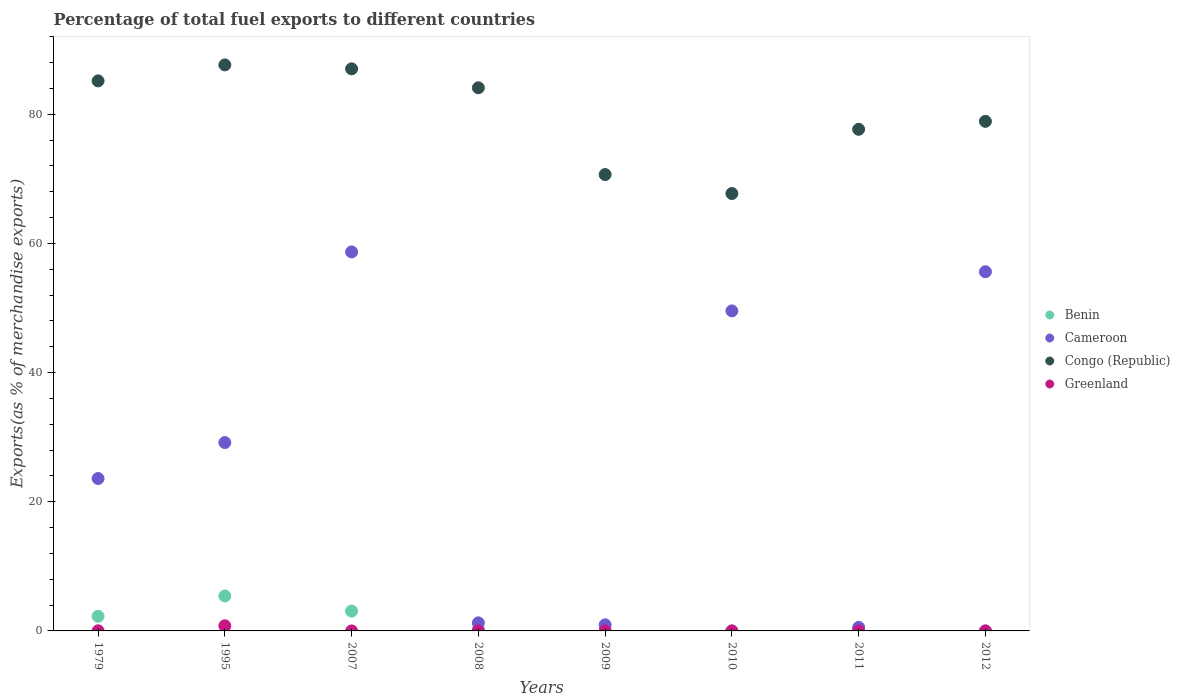How many different coloured dotlines are there?
Provide a succinct answer. 4. Is the number of dotlines equal to the number of legend labels?
Your response must be concise. Yes. What is the percentage of exports to different countries in Greenland in 1979?
Your answer should be very brief. 0.02. Across all years, what is the maximum percentage of exports to different countries in Benin?
Provide a succinct answer. 5.42. Across all years, what is the minimum percentage of exports to different countries in Benin?
Offer a terse response. 0.01. In which year was the percentage of exports to different countries in Congo (Republic) maximum?
Keep it short and to the point. 1995. What is the total percentage of exports to different countries in Greenland in the graph?
Provide a short and direct response. 0.81. What is the difference between the percentage of exports to different countries in Benin in 2010 and that in 2012?
Provide a succinct answer. 0.01. What is the difference between the percentage of exports to different countries in Congo (Republic) in 1979 and the percentage of exports to different countries in Benin in 2011?
Ensure brevity in your answer.  85.06. What is the average percentage of exports to different countries in Greenland per year?
Offer a very short reply. 0.1. In the year 2008, what is the difference between the percentage of exports to different countries in Cameroon and percentage of exports to different countries in Benin?
Provide a succinct answer. 0.98. What is the ratio of the percentage of exports to different countries in Congo (Republic) in 2007 to that in 2012?
Keep it short and to the point. 1.1. Is the difference between the percentage of exports to different countries in Cameroon in 2007 and 2012 greater than the difference between the percentage of exports to different countries in Benin in 2007 and 2012?
Your answer should be compact. Yes. What is the difference between the highest and the second highest percentage of exports to different countries in Benin?
Your answer should be compact. 2.35. What is the difference between the highest and the lowest percentage of exports to different countries in Greenland?
Ensure brevity in your answer.  0.79. Is the percentage of exports to different countries in Greenland strictly greater than the percentage of exports to different countries in Cameroon over the years?
Keep it short and to the point. No. Is the percentage of exports to different countries in Cameroon strictly less than the percentage of exports to different countries in Greenland over the years?
Offer a very short reply. No. How many dotlines are there?
Offer a very short reply. 4. What is the difference between two consecutive major ticks on the Y-axis?
Ensure brevity in your answer.  20. Does the graph contain any zero values?
Ensure brevity in your answer.  No. Where does the legend appear in the graph?
Provide a succinct answer. Center right. What is the title of the graph?
Offer a very short reply. Percentage of total fuel exports to different countries. What is the label or title of the X-axis?
Your answer should be compact. Years. What is the label or title of the Y-axis?
Give a very brief answer. Exports(as % of merchandise exports). What is the Exports(as % of merchandise exports) in Benin in 1979?
Your answer should be very brief. 2.27. What is the Exports(as % of merchandise exports) of Cameroon in 1979?
Provide a succinct answer. 23.6. What is the Exports(as % of merchandise exports) in Congo (Republic) in 1979?
Keep it short and to the point. 85.16. What is the Exports(as % of merchandise exports) in Greenland in 1979?
Provide a short and direct response. 0.02. What is the Exports(as % of merchandise exports) of Benin in 1995?
Give a very brief answer. 5.42. What is the Exports(as % of merchandise exports) of Cameroon in 1995?
Offer a very short reply. 29.16. What is the Exports(as % of merchandise exports) in Congo (Republic) in 1995?
Make the answer very short. 87.64. What is the Exports(as % of merchandise exports) in Greenland in 1995?
Make the answer very short. 0.79. What is the Exports(as % of merchandise exports) of Benin in 2007?
Offer a terse response. 3.07. What is the Exports(as % of merchandise exports) in Cameroon in 2007?
Give a very brief answer. 58.68. What is the Exports(as % of merchandise exports) of Congo (Republic) in 2007?
Ensure brevity in your answer.  87.02. What is the Exports(as % of merchandise exports) of Greenland in 2007?
Offer a terse response. 1.67003405452262e-5. What is the Exports(as % of merchandise exports) of Benin in 2008?
Your answer should be very brief. 0.27. What is the Exports(as % of merchandise exports) in Cameroon in 2008?
Provide a succinct answer. 1.25. What is the Exports(as % of merchandise exports) of Congo (Republic) in 2008?
Your answer should be compact. 84.09. What is the Exports(as % of merchandise exports) of Greenland in 2008?
Your answer should be very brief. 0. What is the Exports(as % of merchandise exports) of Benin in 2009?
Give a very brief answer. 0.01. What is the Exports(as % of merchandise exports) of Cameroon in 2009?
Offer a terse response. 0.95. What is the Exports(as % of merchandise exports) in Congo (Republic) in 2009?
Offer a terse response. 70.66. What is the Exports(as % of merchandise exports) in Greenland in 2009?
Provide a short and direct response. 6.028633814473571e-5. What is the Exports(as % of merchandise exports) of Benin in 2010?
Provide a short and direct response. 0.01. What is the Exports(as % of merchandise exports) in Cameroon in 2010?
Keep it short and to the point. 49.55. What is the Exports(as % of merchandise exports) in Congo (Republic) in 2010?
Provide a short and direct response. 67.72. What is the Exports(as % of merchandise exports) of Greenland in 2010?
Ensure brevity in your answer.  0. What is the Exports(as % of merchandise exports) of Benin in 2011?
Provide a succinct answer. 0.11. What is the Exports(as % of merchandise exports) of Cameroon in 2011?
Your answer should be compact. 0.55. What is the Exports(as % of merchandise exports) of Congo (Republic) in 2011?
Your answer should be very brief. 77.67. What is the Exports(as % of merchandise exports) of Greenland in 2011?
Keep it short and to the point. 0. What is the Exports(as % of merchandise exports) in Benin in 2012?
Ensure brevity in your answer.  0.01. What is the Exports(as % of merchandise exports) in Cameroon in 2012?
Offer a terse response. 55.61. What is the Exports(as % of merchandise exports) of Congo (Republic) in 2012?
Give a very brief answer. 78.9. What is the Exports(as % of merchandise exports) in Greenland in 2012?
Make the answer very short. 0. Across all years, what is the maximum Exports(as % of merchandise exports) in Benin?
Offer a terse response. 5.42. Across all years, what is the maximum Exports(as % of merchandise exports) in Cameroon?
Provide a succinct answer. 58.68. Across all years, what is the maximum Exports(as % of merchandise exports) in Congo (Republic)?
Your answer should be compact. 87.64. Across all years, what is the maximum Exports(as % of merchandise exports) of Greenland?
Provide a short and direct response. 0.79. Across all years, what is the minimum Exports(as % of merchandise exports) in Benin?
Your answer should be compact. 0.01. Across all years, what is the minimum Exports(as % of merchandise exports) of Cameroon?
Your response must be concise. 0.55. Across all years, what is the minimum Exports(as % of merchandise exports) in Congo (Republic)?
Make the answer very short. 67.72. Across all years, what is the minimum Exports(as % of merchandise exports) in Greenland?
Provide a short and direct response. 1.67003405452262e-5. What is the total Exports(as % of merchandise exports) of Benin in the graph?
Give a very brief answer. 11.15. What is the total Exports(as % of merchandise exports) in Cameroon in the graph?
Give a very brief answer. 219.35. What is the total Exports(as % of merchandise exports) in Congo (Republic) in the graph?
Give a very brief answer. 638.87. What is the total Exports(as % of merchandise exports) in Greenland in the graph?
Make the answer very short. 0.81. What is the difference between the Exports(as % of merchandise exports) of Benin in 1979 and that in 1995?
Your answer should be very brief. -3.15. What is the difference between the Exports(as % of merchandise exports) of Cameroon in 1979 and that in 1995?
Offer a very short reply. -5.57. What is the difference between the Exports(as % of merchandise exports) of Congo (Republic) in 1979 and that in 1995?
Ensure brevity in your answer.  -2.48. What is the difference between the Exports(as % of merchandise exports) of Greenland in 1979 and that in 1995?
Give a very brief answer. -0.77. What is the difference between the Exports(as % of merchandise exports) in Benin in 1979 and that in 2007?
Your answer should be compact. -0.8. What is the difference between the Exports(as % of merchandise exports) of Cameroon in 1979 and that in 2007?
Your answer should be compact. -35.08. What is the difference between the Exports(as % of merchandise exports) in Congo (Republic) in 1979 and that in 2007?
Make the answer very short. -1.86. What is the difference between the Exports(as % of merchandise exports) of Greenland in 1979 and that in 2007?
Make the answer very short. 0.02. What is the difference between the Exports(as % of merchandise exports) of Benin in 1979 and that in 2008?
Ensure brevity in your answer.  2. What is the difference between the Exports(as % of merchandise exports) in Cameroon in 1979 and that in 2008?
Make the answer very short. 22.35. What is the difference between the Exports(as % of merchandise exports) in Congo (Republic) in 1979 and that in 2008?
Provide a succinct answer. 1.07. What is the difference between the Exports(as % of merchandise exports) in Greenland in 1979 and that in 2008?
Your response must be concise. 0.02. What is the difference between the Exports(as % of merchandise exports) in Benin in 1979 and that in 2009?
Offer a very short reply. 2.26. What is the difference between the Exports(as % of merchandise exports) of Cameroon in 1979 and that in 2009?
Your answer should be compact. 22.65. What is the difference between the Exports(as % of merchandise exports) in Congo (Republic) in 1979 and that in 2009?
Ensure brevity in your answer.  14.5. What is the difference between the Exports(as % of merchandise exports) in Greenland in 1979 and that in 2009?
Give a very brief answer. 0.02. What is the difference between the Exports(as % of merchandise exports) in Benin in 1979 and that in 2010?
Give a very brief answer. 2.26. What is the difference between the Exports(as % of merchandise exports) in Cameroon in 1979 and that in 2010?
Provide a succinct answer. -25.95. What is the difference between the Exports(as % of merchandise exports) in Congo (Republic) in 1979 and that in 2010?
Keep it short and to the point. 17.44. What is the difference between the Exports(as % of merchandise exports) in Greenland in 1979 and that in 2010?
Your answer should be compact. 0.02. What is the difference between the Exports(as % of merchandise exports) of Benin in 1979 and that in 2011?
Offer a terse response. 2.16. What is the difference between the Exports(as % of merchandise exports) in Cameroon in 1979 and that in 2011?
Provide a succinct answer. 23.05. What is the difference between the Exports(as % of merchandise exports) of Congo (Republic) in 1979 and that in 2011?
Your response must be concise. 7.5. What is the difference between the Exports(as % of merchandise exports) in Greenland in 1979 and that in 2011?
Provide a short and direct response. 0.02. What is the difference between the Exports(as % of merchandise exports) in Benin in 1979 and that in 2012?
Your response must be concise. 2.27. What is the difference between the Exports(as % of merchandise exports) of Cameroon in 1979 and that in 2012?
Ensure brevity in your answer.  -32.01. What is the difference between the Exports(as % of merchandise exports) of Congo (Republic) in 1979 and that in 2012?
Keep it short and to the point. 6.26. What is the difference between the Exports(as % of merchandise exports) in Greenland in 1979 and that in 2012?
Give a very brief answer. 0.02. What is the difference between the Exports(as % of merchandise exports) of Benin in 1995 and that in 2007?
Keep it short and to the point. 2.35. What is the difference between the Exports(as % of merchandise exports) in Cameroon in 1995 and that in 2007?
Make the answer very short. -29.52. What is the difference between the Exports(as % of merchandise exports) in Congo (Republic) in 1995 and that in 2007?
Your answer should be compact. 0.62. What is the difference between the Exports(as % of merchandise exports) in Greenland in 1995 and that in 2007?
Keep it short and to the point. 0.79. What is the difference between the Exports(as % of merchandise exports) in Benin in 1995 and that in 2008?
Offer a terse response. 5.15. What is the difference between the Exports(as % of merchandise exports) in Cameroon in 1995 and that in 2008?
Provide a succinct answer. 27.92. What is the difference between the Exports(as % of merchandise exports) of Congo (Republic) in 1995 and that in 2008?
Your response must be concise. 3.55. What is the difference between the Exports(as % of merchandise exports) in Greenland in 1995 and that in 2008?
Your response must be concise. 0.79. What is the difference between the Exports(as % of merchandise exports) of Benin in 1995 and that in 2009?
Offer a terse response. 5.41. What is the difference between the Exports(as % of merchandise exports) in Cameroon in 1995 and that in 2009?
Give a very brief answer. 28.22. What is the difference between the Exports(as % of merchandise exports) of Congo (Republic) in 1995 and that in 2009?
Make the answer very short. 16.98. What is the difference between the Exports(as % of merchandise exports) of Greenland in 1995 and that in 2009?
Your answer should be compact. 0.79. What is the difference between the Exports(as % of merchandise exports) in Benin in 1995 and that in 2010?
Provide a succinct answer. 5.4. What is the difference between the Exports(as % of merchandise exports) in Cameroon in 1995 and that in 2010?
Your answer should be very brief. -20.38. What is the difference between the Exports(as % of merchandise exports) of Congo (Republic) in 1995 and that in 2010?
Provide a succinct answer. 19.92. What is the difference between the Exports(as % of merchandise exports) of Greenland in 1995 and that in 2010?
Give a very brief answer. 0.79. What is the difference between the Exports(as % of merchandise exports) in Benin in 1995 and that in 2011?
Provide a short and direct response. 5.31. What is the difference between the Exports(as % of merchandise exports) of Cameroon in 1995 and that in 2011?
Offer a terse response. 28.61. What is the difference between the Exports(as % of merchandise exports) of Congo (Republic) in 1995 and that in 2011?
Offer a very short reply. 9.97. What is the difference between the Exports(as % of merchandise exports) of Greenland in 1995 and that in 2011?
Provide a succinct answer. 0.79. What is the difference between the Exports(as % of merchandise exports) in Benin in 1995 and that in 2012?
Keep it short and to the point. 5.41. What is the difference between the Exports(as % of merchandise exports) in Cameroon in 1995 and that in 2012?
Your response must be concise. -26.45. What is the difference between the Exports(as % of merchandise exports) of Congo (Republic) in 1995 and that in 2012?
Give a very brief answer. 8.74. What is the difference between the Exports(as % of merchandise exports) of Greenland in 1995 and that in 2012?
Your response must be concise. 0.79. What is the difference between the Exports(as % of merchandise exports) of Benin in 2007 and that in 2008?
Keep it short and to the point. 2.8. What is the difference between the Exports(as % of merchandise exports) in Cameroon in 2007 and that in 2008?
Give a very brief answer. 57.43. What is the difference between the Exports(as % of merchandise exports) in Congo (Republic) in 2007 and that in 2008?
Provide a succinct answer. 2.93. What is the difference between the Exports(as % of merchandise exports) of Greenland in 2007 and that in 2008?
Offer a terse response. -0. What is the difference between the Exports(as % of merchandise exports) in Benin in 2007 and that in 2009?
Make the answer very short. 3.06. What is the difference between the Exports(as % of merchandise exports) of Cameroon in 2007 and that in 2009?
Give a very brief answer. 57.73. What is the difference between the Exports(as % of merchandise exports) of Congo (Republic) in 2007 and that in 2009?
Your answer should be compact. 16.37. What is the difference between the Exports(as % of merchandise exports) in Benin in 2007 and that in 2010?
Your answer should be compact. 3.06. What is the difference between the Exports(as % of merchandise exports) of Cameroon in 2007 and that in 2010?
Your response must be concise. 9.13. What is the difference between the Exports(as % of merchandise exports) of Congo (Republic) in 2007 and that in 2010?
Your answer should be compact. 19.3. What is the difference between the Exports(as % of merchandise exports) of Greenland in 2007 and that in 2010?
Your answer should be compact. -0. What is the difference between the Exports(as % of merchandise exports) of Benin in 2007 and that in 2011?
Keep it short and to the point. 2.96. What is the difference between the Exports(as % of merchandise exports) of Cameroon in 2007 and that in 2011?
Your response must be concise. 58.13. What is the difference between the Exports(as % of merchandise exports) of Congo (Republic) in 2007 and that in 2011?
Provide a succinct answer. 9.36. What is the difference between the Exports(as % of merchandise exports) of Greenland in 2007 and that in 2011?
Make the answer very short. -0. What is the difference between the Exports(as % of merchandise exports) in Benin in 2007 and that in 2012?
Your response must be concise. 3.06. What is the difference between the Exports(as % of merchandise exports) in Cameroon in 2007 and that in 2012?
Provide a succinct answer. 3.07. What is the difference between the Exports(as % of merchandise exports) in Congo (Republic) in 2007 and that in 2012?
Ensure brevity in your answer.  8.13. What is the difference between the Exports(as % of merchandise exports) in Greenland in 2007 and that in 2012?
Provide a short and direct response. -0. What is the difference between the Exports(as % of merchandise exports) of Benin in 2008 and that in 2009?
Your answer should be compact. 0.26. What is the difference between the Exports(as % of merchandise exports) in Cameroon in 2008 and that in 2009?
Provide a succinct answer. 0.3. What is the difference between the Exports(as % of merchandise exports) of Congo (Republic) in 2008 and that in 2009?
Your response must be concise. 13.44. What is the difference between the Exports(as % of merchandise exports) in Benin in 2008 and that in 2010?
Make the answer very short. 0.26. What is the difference between the Exports(as % of merchandise exports) in Cameroon in 2008 and that in 2010?
Ensure brevity in your answer.  -48.3. What is the difference between the Exports(as % of merchandise exports) of Congo (Republic) in 2008 and that in 2010?
Keep it short and to the point. 16.37. What is the difference between the Exports(as % of merchandise exports) in Greenland in 2008 and that in 2010?
Provide a succinct answer. -0. What is the difference between the Exports(as % of merchandise exports) of Benin in 2008 and that in 2011?
Give a very brief answer. 0.16. What is the difference between the Exports(as % of merchandise exports) in Cameroon in 2008 and that in 2011?
Ensure brevity in your answer.  0.69. What is the difference between the Exports(as % of merchandise exports) in Congo (Republic) in 2008 and that in 2011?
Ensure brevity in your answer.  6.43. What is the difference between the Exports(as % of merchandise exports) of Greenland in 2008 and that in 2011?
Offer a very short reply. 0. What is the difference between the Exports(as % of merchandise exports) in Benin in 2008 and that in 2012?
Keep it short and to the point. 0.26. What is the difference between the Exports(as % of merchandise exports) of Cameroon in 2008 and that in 2012?
Offer a terse response. -54.36. What is the difference between the Exports(as % of merchandise exports) in Congo (Republic) in 2008 and that in 2012?
Make the answer very short. 5.2. What is the difference between the Exports(as % of merchandise exports) in Benin in 2009 and that in 2010?
Offer a very short reply. -0. What is the difference between the Exports(as % of merchandise exports) in Cameroon in 2009 and that in 2010?
Your response must be concise. -48.6. What is the difference between the Exports(as % of merchandise exports) in Congo (Republic) in 2009 and that in 2010?
Ensure brevity in your answer.  2.94. What is the difference between the Exports(as % of merchandise exports) of Greenland in 2009 and that in 2010?
Provide a succinct answer. -0. What is the difference between the Exports(as % of merchandise exports) of Benin in 2009 and that in 2011?
Give a very brief answer. -0.1. What is the difference between the Exports(as % of merchandise exports) of Cameroon in 2009 and that in 2011?
Your answer should be compact. 0.4. What is the difference between the Exports(as % of merchandise exports) of Congo (Republic) in 2009 and that in 2011?
Make the answer very short. -7.01. What is the difference between the Exports(as % of merchandise exports) of Greenland in 2009 and that in 2011?
Provide a succinct answer. -0. What is the difference between the Exports(as % of merchandise exports) of Benin in 2009 and that in 2012?
Provide a short and direct response. 0. What is the difference between the Exports(as % of merchandise exports) of Cameroon in 2009 and that in 2012?
Your answer should be very brief. -54.66. What is the difference between the Exports(as % of merchandise exports) in Congo (Republic) in 2009 and that in 2012?
Offer a terse response. -8.24. What is the difference between the Exports(as % of merchandise exports) of Greenland in 2009 and that in 2012?
Ensure brevity in your answer.  -0. What is the difference between the Exports(as % of merchandise exports) of Benin in 2010 and that in 2011?
Ensure brevity in your answer.  -0.09. What is the difference between the Exports(as % of merchandise exports) in Cameroon in 2010 and that in 2011?
Your response must be concise. 49. What is the difference between the Exports(as % of merchandise exports) of Congo (Republic) in 2010 and that in 2011?
Give a very brief answer. -9.95. What is the difference between the Exports(as % of merchandise exports) of Greenland in 2010 and that in 2011?
Make the answer very short. 0. What is the difference between the Exports(as % of merchandise exports) of Benin in 2010 and that in 2012?
Offer a very short reply. 0.01. What is the difference between the Exports(as % of merchandise exports) in Cameroon in 2010 and that in 2012?
Keep it short and to the point. -6.06. What is the difference between the Exports(as % of merchandise exports) of Congo (Republic) in 2010 and that in 2012?
Your answer should be very brief. -11.18. What is the difference between the Exports(as % of merchandise exports) in Greenland in 2010 and that in 2012?
Your answer should be compact. 0. What is the difference between the Exports(as % of merchandise exports) in Benin in 2011 and that in 2012?
Your answer should be very brief. 0.1. What is the difference between the Exports(as % of merchandise exports) in Cameroon in 2011 and that in 2012?
Offer a very short reply. -55.06. What is the difference between the Exports(as % of merchandise exports) in Congo (Republic) in 2011 and that in 2012?
Your response must be concise. -1.23. What is the difference between the Exports(as % of merchandise exports) of Greenland in 2011 and that in 2012?
Provide a succinct answer. 0. What is the difference between the Exports(as % of merchandise exports) of Benin in 1979 and the Exports(as % of merchandise exports) of Cameroon in 1995?
Your answer should be compact. -26.89. What is the difference between the Exports(as % of merchandise exports) of Benin in 1979 and the Exports(as % of merchandise exports) of Congo (Republic) in 1995?
Your answer should be very brief. -85.37. What is the difference between the Exports(as % of merchandise exports) of Benin in 1979 and the Exports(as % of merchandise exports) of Greenland in 1995?
Make the answer very short. 1.48. What is the difference between the Exports(as % of merchandise exports) of Cameroon in 1979 and the Exports(as % of merchandise exports) of Congo (Republic) in 1995?
Provide a succinct answer. -64.04. What is the difference between the Exports(as % of merchandise exports) of Cameroon in 1979 and the Exports(as % of merchandise exports) of Greenland in 1995?
Give a very brief answer. 22.8. What is the difference between the Exports(as % of merchandise exports) of Congo (Republic) in 1979 and the Exports(as % of merchandise exports) of Greenland in 1995?
Your answer should be compact. 84.37. What is the difference between the Exports(as % of merchandise exports) in Benin in 1979 and the Exports(as % of merchandise exports) in Cameroon in 2007?
Give a very brief answer. -56.41. What is the difference between the Exports(as % of merchandise exports) of Benin in 1979 and the Exports(as % of merchandise exports) of Congo (Republic) in 2007?
Keep it short and to the point. -84.75. What is the difference between the Exports(as % of merchandise exports) in Benin in 1979 and the Exports(as % of merchandise exports) in Greenland in 2007?
Your answer should be very brief. 2.27. What is the difference between the Exports(as % of merchandise exports) in Cameroon in 1979 and the Exports(as % of merchandise exports) in Congo (Republic) in 2007?
Your response must be concise. -63.43. What is the difference between the Exports(as % of merchandise exports) of Cameroon in 1979 and the Exports(as % of merchandise exports) of Greenland in 2007?
Your response must be concise. 23.6. What is the difference between the Exports(as % of merchandise exports) of Congo (Republic) in 1979 and the Exports(as % of merchandise exports) of Greenland in 2007?
Your answer should be very brief. 85.16. What is the difference between the Exports(as % of merchandise exports) of Benin in 1979 and the Exports(as % of merchandise exports) of Congo (Republic) in 2008?
Make the answer very short. -81.82. What is the difference between the Exports(as % of merchandise exports) of Benin in 1979 and the Exports(as % of merchandise exports) of Greenland in 2008?
Make the answer very short. 2.27. What is the difference between the Exports(as % of merchandise exports) of Cameroon in 1979 and the Exports(as % of merchandise exports) of Congo (Republic) in 2008?
Provide a succinct answer. -60.5. What is the difference between the Exports(as % of merchandise exports) in Cameroon in 1979 and the Exports(as % of merchandise exports) in Greenland in 2008?
Your answer should be very brief. 23.6. What is the difference between the Exports(as % of merchandise exports) in Congo (Republic) in 1979 and the Exports(as % of merchandise exports) in Greenland in 2008?
Make the answer very short. 85.16. What is the difference between the Exports(as % of merchandise exports) of Benin in 1979 and the Exports(as % of merchandise exports) of Cameroon in 2009?
Provide a short and direct response. 1.32. What is the difference between the Exports(as % of merchandise exports) of Benin in 1979 and the Exports(as % of merchandise exports) of Congo (Republic) in 2009?
Offer a very short reply. -68.39. What is the difference between the Exports(as % of merchandise exports) of Benin in 1979 and the Exports(as % of merchandise exports) of Greenland in 2009?
Your answer should be compact. 2.27. What is the difference between the Exports(as % of merchandise exports) in Cameroon in 1979 and the Exports(as % of merchandise exports) in Congo (Republic) in 2009?
Offer a terse response. -47.06. What is the difference between the Exports(as % of merchandise exports) in Cameroon in 1979 and the Exports(as % of merchandise exports) in Greenland in 2009?
Provide a succinct answer. 23.6. What is the difference between the Exports(as % of merchandise exports) of Congo (Republic) in 1979 and the Exports(as % of merchandise exports) of Greenland in 2009?
Give a very brief answer. 85.16. What is the difference between the Exports(as % of merchandise exports) of Benin in 1979 and the Exports(as % of merchandise exports) of Cameroon in 2010?
Your answer should be very brief. -47.28. What is the difference between the Exports(as % of merchandise exports) in Benin in 1979 and the Exports(as % of merchandise exports) in Congo (Republic) in 2010?
Make the answer very short. -65.45. What is the difference between the Exports(as % of merchandise exports) of Benin in 1979 and the Exports(as % of merchandise exports) of Greenland in 2010?
Offer a very short reply. 2.27. What is the difference between the Exports(as % of merchandise exports) in Cameroon in 1979 and the Exports(as % of merchandise exports) in Congo (Republic) in 2010?
Offer a terse response. -44.12. What is the difference between the Exports(as % of merchandise exports) of Cameroon in 1979 and the Exports(as % of merchandise exports) of Greenland in 2010?
Provide a succinct answer. 23.6. What is the difference between the Exports(as % of merchandise exports) of Congo (Republic) in 1979 and the Exports(as % of merchandise exports) of Greenland in 2010?
Your answer should be very brief. 85.16. What is the difference between the Exports(as % of merchandise exports) of Benin in 1979 and the Exports(as % of merchandise exports) of Cameroon in 2011?
Provide a succinct answer. 1.72. What is the difference between the Exports(as % of merchandise exports) in Benin in 1979 and the Exports(as % of merchandise exports) in Congo (Republic) in 2011?
Provide a short and direct response. -75.4. What is the difference between the Exports(as % of merchandise exports) in Benin in 1979 and the Exports(as % of merchandise exports) in Greenland in 2011?
Your answer should be compact. 2.27. What is the difference between the Exports(as % of merchandise exports) in Cameroon in 1979 and the Exports(as % of merchandise exports) in Congo (Republic) in 2011?
Your response must be concise. -54.07. What is the difference between the Exports(as % of merchandise exports) of Cameroon in 1979 and the Exports(as % of merchandise exports) of Greenland in 2011?
Provide a short and direct response. 23.6. What is the difference between the Exports(as % of merchandise exports) in Congo (Republic) in 1979 and the Exports(as % of merchandise exports) in Greenland in 2011?
Your answer should be compact. 85.16. What is the difference between the Exports(as % of merchandise exports) of Benin in 1979 and the Exports(as % of merchandise exports) of Cameroon in 2012?
Offer a very short reply. -53.34. What is the difference between the Exports(as % of merchandise exports) of Benin in 1979 and the Exports(as % of merchandise exports) of Congo (Republic) in 2012?
Your answer should be compact. -76.63. What is the difference between the Exports(as % of merchandise exports) of Benin in 1979 and the Exports(as % of merchandise exports) of Greenland in 2012?
Provide a succinct answer. 2.27. What is the difference between the Exports(as % of merchandise exports) of Cameroon in 1979 and the Exports(as % of merchandise exports) of Congo (Republic) in 2012?
Provide a short and direct response. -55.3. What is the difference between the Exports(as % of merchandise exports) of Cameroon in 1979 and the Exports(as % of merchandise exports) of Greenland in 2012?
Make the answer very short. 23.6. What is the difference between the Exports(as % of merchandise exports) in Congo (Republic) in 1979 and the Exports(as % of merchandise exports) in Greenland in 2012?
Offer a terse response. 85.16. What is the difference between the Exports(as % of merchandise exports) in Benin in 1995 and the Exports(as % of merchandise exports) in Cameroon in 2007?
Provide a short and direct response. -53.27. What is the difference between the Exports(as % of merchandise exports) in Benin in 1995 and the Exports(as % of merchandise exports) in Congo (Republic) in 2007?
Keep it short and to the point. -81.61. What is the difference between the Exports(as % of merchandise exports) in Benin in 1995 and the Exports(as % of merchandise exports) in Greenland in 2007?
Your answer should be very brief. 5.42. What is the difference between the Exports(as % of merchandise exports) in Cameroon in 1995 and the Exports(as % of merchandise exports) in Congo (Republic) in 2007?
Keep it short and to the point. -57.86. What is the difference between the Exports(as % of merchandise exports) of Cameroon in 1995 and the Exports(as % of merchandise exports) of Greenland in 2007?
Keep it short and to the point. 29.16. What is the difference between the Exports(as % of merchandise exports) in Congo (Republic) in 1995 and the Exports(as % of merchandise exports) in Greenland in 2007?
Ensure brevity in your answer.  87.64. What is the difference between the Exports(as % of merchandise exports) in Benin in 1995 and the Exports(as % of merchandise exports) in Cameroon in 2008?
Offer a terse response. 4.17. What is the difference between the Exports(as % of merchandise exports) of Benin in 1995 and the Exports(as % of merchandise exports) of Congo (Republic) in 2008?
Make the answer very short. -78.68. What is the difference between the Exports(as % of merchandise exports) of Benin in 1995 and the Exports(as % of merchandise exports) of Greenland in 2008?
Offer a terse response. 5.42. What is the difference between the Exports(as % of merchandise exports) of Cameroon in 1995 and the Exports(as % of merchandise exports) of Congo (Republic) in 2008?
Make the answer very short. -54.93. What is the difference between the Exports(as % of merchandise exports) of Cameroon in 1995 and the Exports(as % of merchandise exports) of Greenland in 2008?
Offer a very short reply. 29.16. What is the difference between the Exports(as % of merchandise exports) in Congo (Republic) in 1995 and the Exports(as % of merchandise exports) in Greenland in 2008?
Offer a very short reply. 87.64. What is the difference between the Exports(as % of merchandise exports) in Benin in 1995 and the Exports(as % of merchandise exports) in Cameroon in 2009?
Your response must be concise. 4.47. What is the difference between the Exports(as % of merchandise exports) of Benin in 1995 and the Exports(as % of merchandise exports) of Congo (Republic) in 2009?
Offer a terse response. -65.24. What is the difference between the Exports(as % of merchandise exports) in Benin in 1995 and the Exports(as % of merchandise exports) in Greenland in 2009?
Keep it short and to the point. 5.42. What is the difference between the Exports(as % of merchandise exports) in Cameroon in 1995 and the Exports(as % of merchandise exports) in Congo (Republic) in 2009?
Provide a succinct answer. -41.5. What is the difference between the Exports(as % of merchandise exports) in Cameroon in 1995 and the Exports(as % of merchandise exports) in Greenland in 2009?
Your response must be concise. 29.16. What is the difference between the Exports(as % of merchandise exports) in Congo (Republic) in 1995 and the Exports(as % of merchandise exports) in Greenland in 2009?
Keep it short and to the point. 87.64. What is the difference between the Exports(as % of merchandise exports) in Benin in 1995 and the Exports(as % of merchandise exports) in Cameroon in 2010?
Give a very brief answer. -44.13. What is the difference between the Exports(as % of merchandise exports) in Benin in 1995 and the Exports(as % of merchandise exports) in Congo (Republic) in 2010?
Give a very brief answer. -62.3. What is the difference between the Exports(as % of merchandise exports) of Benin in 1995 and the Exports(as % of merchandise exports) of Greenland in 2010?
Your response must be concise. 5.42. What is the difference between the Exports(as % of merchandise exports) in Cameroon in 1995 and the Exports(as % of merchandise exports) in Congo (Republic) in 2010?
Your answer should be compact. -38.56. What is the difference between the Exports(as % of merchandise exports) in Cameroon in 1995 and the Exports(as % of merchandise exports) in Greenland in 2010?
Keep it short and to the point. 29.16. What is the difference between the Exports(as % of merchandise exports) of Congo (Republic) in 1995 and the Exports(as % of merchandise exports) of Greenland in 2010?
Give a very brief answer. 87.64. What is the difference between the Exports(as % of merchandise exports) of Benin in 1995 and the Exports(as % of merchandise exports) of Cameroon in 2011?
Give a very brief answer. 4.86. What is the difference between the Exports(as % of merchandise exports) of Benin in 1995 and the Exports(as % of merchandise exports) of Congo (Republic) in 2011?
Provide a short and direct response. -72.25. What is the difference between the Exports(as % of merchandise exports) of Benin in 1995 and the Exports(as % of merchandise exports) of Greenland in 2011?
Offer a very short reply. 5.42. What is the difference between the Exports(as % of merchandise exports) of Cameroon in 1995 and the Exports(as % of merchandise exports) of Congo (Republic) in 2011?
Keep it short and to the point. -48.5. What is the difference between the Exports(as % of merchandise exports) of Cameroon in 1995 and the Exports(as % of merchandise exports) of Greenland in 2011?
Give a very brief answer. 29.16. What is the difference between the Exports(as % of merchandise exports) of Congo (Republic) in 1995 and the Exports(as % of merchandise exports) of Greenland in 2011?
Offer a very short reply. 87.64. What is the difference between the Exports(as % of merchandise exports) of Benin in 1995 and the Exports(as % of merchandise exports) of Cameroon in 2012?
Your answer should be compact. -50.2. What is the difference between the Exports(as % of merchandise exports) of Benin in 1995 and the Exports(as % of merchandise exports) of Congo (Republic) in 2012?
Provide a succinct answer. -73.48. What is the difference between the Exports(as % of merchandise exports) in Benin in 1995 and the Exports(as % of merchandise exports) in Greenland in 2012?
Keep it short and to the point. 5.42. What is the difference between the Exports(as % of merchandise exports) in Cameroon in 1995 and the Exports(as % of merchandise exports) in Congo (Republic) in 2012?
Provide a short and direct response. -49.73. What is the difference between the Exports(as % of merchandise exports) in Cameroon in 1995 and the Exports(as % of merchandise exports) in Greenland in 2012?
Give a very brief answer. 29.16. What is the difference between the Exports(as % of merchandise exports) of Congo (Republic) in 1995 and the Exports(as % of merchandise exports) of Greenland in 2012?
Your response must be concise. 87.64. What is the difference between the Exports(as % of merchandise exports) of Benin in 2007 and the Exports(as % of merchandise exports) of Cameroon in 2008?
Provide a short and direct response. 1.82. What is the difference between the Exports(as % of merchandise exports) in Benin in 2007 and the Exports(as % of merchandise exports) in Congo (Republic) in 2008?
Your answer should be very brief. -81.03. What is the difference between the Exports(as % of merchandise exports) of Benin in 2007 and the Exports(as % of merchandise exports) of Greenland in 2008?
Your answer should be compact. 3.07. What is the difference between the Exports(as % of merchandise exports) in Cameroon in 2007 and the Exports(as % of merchandise exports) in Congo (Republic) in 2008?
Give a very brief answer. -25.41. What is the difference between the Exports(as % of merchandise exports) of Cameroon in 2007 and the Exports(as % of merchandise exports) of Greenland in 2008?
Offer a terse response. 58.68. What is the difference between the Exports(as % of merchandise exports) in Congo (Republic) in 2007 and the Exports(as % of merchandise exports) in Greenland in 2008?
Keep it short and to the point. 87.02. What is the difference between the Exports(as % of merchandise exports) in Benin in 2007 and the Exports(as % of merchandise exports) in Cameroon in 2009?
Provide a succinct answer. 2.12. What is the difference between the Exports(as % of merchandise exports) in Benin in 2007 and the Exports(as % of merchandise exports) in Congo (Republic) in 2009?
Your answer should be very brief. -67.59. What is the difference between the Exports(as % of merchandise exports) of Benin in 2007 and the Exports(as % of merchandise exports) of Greenland in 2009?
Your response must be concise. 3.07. What is the difference between the Exports(as % of merchandise exports) of Cameroon in 2007 and the Exports(as % of merchandise exports) of Congo (Republic) in 2009?
Make the answer very short. -11.98. What is the difference between the Exports(as % of merchandise exports) of Cameroon in 2007 and the Exports(as % of merchandise exports) of Greenland in 2009?
Make the answer very short. 58.68. What is the difference between the Exports(as % of merchandise exports) in Congo (Republic) in 2007 and the Exports(as % of merchandise exports) in Greenland in 2009?
Ensure brevity in your answer.  87.02. What is the difference between the Exports(as % of merchandise exports) of Benin in 2007 and the Exports(as % of merchandise exports) of Cameroon in 2010?
Your response must be concise. -46.48. What is the difference between the Exports(as % of merchandise exports) in Benin in 2007 and the Exports(as % of merchandise exports) in Congo (Republic) in 2010?
Ensure brevity in your answer.  -64.65. What is the difference between the Exports(as % of merchandise exports) of Benin in 2007 and the Exports(as % of merchandise exports) of Greenland in 2010?
Make the answer very short. 3.07. What is the difference between the Exports(as % of merchandise exports) of Cameroon in 2007 and the Exports(as % of merchandise exports) of Congo (Republic) in 2010?
Provide a short and direct response. -9.04. What is the difference between the Exports(as % of merchandise exports) in Cameroon in 2007 and the Exports(as % of merchandise exports) in Greenland in 2010?
Provide a succinct answer. 58.68. What is the difference between the Exports(as % of merchandise exports) in Congo (Republic) in 2007 and the Exports(as % of merchandise exports) in Greenland in 2010?
Keep it short and to the point. 87.02. What is the difference between the Exports(as % of merchandise exports) in Benin in 2007 and the Exports(as % of merchandise exports) in Cameroon in 2011?
Provide a short and direct response. 2.51. What is the difference between the Exports(as % of merchandise exports) of Benin in 2007 and the Exports(as % of merchandise exports) of Congo (Republic) in 2011?
Make the answer very short. -74.6. What is the difference between the Exports(as % of merchandise exports) of Benin in 2007 and the Exports(as % of merchandise exports) of Greenland in 2011?
Provide a short and direct response. 3.07. What is the difference between the Exports(as % of merchandise exports) in Cameroon in 2007 and the Exports(as % of merchandise exports) in Congo (Republic) in 2011?
Offer a terse response. -18.99. What is the difference between the Exports(as % of merchandise exports) in Cameroon in 2007 and the Exports(as % of merchandise exports) in Greenland in 2011?
Your response must be concise. 58.68. What is the difference between the Exports(as % of merchandise exports) in Congo (Republic) in 2007 and the Exports(as % of merchandise exports) in Greenland in 2011?
Keep it short and to the point. 87.02. What is the difference between the Exports(as % of merchandise exports) in Benin in 2007 and the Exports(as % of merchandise exports) in Cameroon in 2012?
Provide a succinct answer. -52.55. What is the difference between the Exports(as % of merchandise exports) in Benin in 2007 and the Exports(as % of merchandise exports) in Congo (Republic) in 2012?
Make the answer very short. -75.83. What is the difference between the Exports(as % of merchandise exports) in Benin in 2007 and the Exports(as % of merchandise exports) in Greenland in 2012?
Make the answer very short. 3.07. What is the difference between the Exports(as % of merchandise exports) of Cameroon in 2007 and the Exports(as % of merchandise exports) of Congo (Republic) in 2012?
Keep it short and to the point. -20.22. What is the difference between the Exports(as % of merchandise exports) in Cameroon in 2007 and the Exports(as % of merchandise exports) in Greenland in 2012?
Offer a very short reply. 58.68. What is the difference between the Exports(as % of merchandise exports) of Congo (Republic) in 2007 and the Exports(as % of merchandise exports) of Greenland in 2012?
Keep it short and to the point. 87.02. What is the difference between the Exports(as % of merchandise exports) of Benin in 2008 and the Exports(as % of merchandise exports) of Cameroon in 2009?
Your answer should be very brief. -0.68. What is the difference between the Exports(as % of merchandise exports) in Benin in 2008 and the Exports(as % of merchandise exports) in Congo (Republic) in 2009?
Ensure brevity in your answer.  -70.39. What is the difference between the Exports(as % of merchandise exports) of Benin in 2008 and the Exports(as % of merchandise exports) of Greenland in 2009?
Give a very brief answer. 0.27. What is the difference between the Exports(as % of merchandise exports) in Cameroon in 2008 and the Exports(as % of merchandise exports) in Congo (Republic) in 2009?
Keep it short and to the point. -69.41. What is the difference between the Exports(as % of merchandise exports) of Cameroon in 2008 and the Exports(as % of merchandise exports) of Greenland in 2009?
Ensure brevity in your answer.  1.25. What is the difference between the Exports(as % of merchandise exports) in Congo (Republic) in 2008 and the Exports(as % of merchandise exports) in Greenland in 2009?
Your answer should be compact. 84.09. What is the difference between the Exports(as % of merchandise exports) in Benin in 2008 and the Exports(as % of merchandise exports) in Cameroon in 2010?
Make the answer very short. -49.28. What is the difference between the Exports(as % of merchandise exports) in Benin in 2008 and the Exports(as % of merchandise exports) in Congo (Republic) in 2010?
Ensure brevity in your answer.  -67.45. What is the difference between the Exports(as % of merchandise exports) of Benin in 2008 and the Exports(as % of merchandise exports) of Greenland in 2010?
Your answer should be compact. 0.27. What is the difference between the Exports(as % of merchandise exports) of Cameroon in 2008 and the Exports(as % of merchandise exports) of Congo (Republic) in 2010?
Provide a succinct answer. -66.47. What is the difference between the Exports(as % of merchandise exports) of Cameroon in 2008 and the Exports(as % of merchandise exports) of Greenland in 2010?
Your answer should be very brief. 1.25. What is the difference between the Exports(as % of merchandise exports) in Congo (Republic) in 2008 and the Exports(as % of merchandise exports) in Greenland in 2010?
Give a very brief answer. 84.09. What is the difference between the Exports(as % of merchandise exports) of Benin in 2008 and the Exports(as % of merchandise exports) of Cameroon in 2011?
Your answer should be very brief. -0.29. What is the difference between the Exports(as % of merchandise exports) of Benin in 2008 and the Exports(as % of merchandise exports) of Congo (Republic) in 2011?
Provide a succinct answer. -77.4. What is the difference between the Exports(as % of merchandise exports) of Benin in 2008 and the Exports(as % of merchandise exports) of Greenland in 2011?
Offer a very short reply. 0.27. What is the difference between the Exports(as % of merchandise exports) of Cameroon in 2008 and the Exports(as % of merchandise exports) of Congo (Republic) in 2011?
Offer a terse response. -76.42. What is the difference between the Exports(as % of merchandise exports) in Cameroon in 2008 and the Exports(as % of merchandise exports) in Greenland in 2011?
Ensure brevity in your answer.  1.25. What is the difference between the Exports(as % of merchandise exports) of Congo (Republic) in 2008 and the Exports(as % of merchandise exports) of Greenland in 2011?
Your response must be concise. 84.09. What is the difference between the Exports(as % of merchandise exports) in Benin in 2008 and the Exports(as % of merchandise exports) in Cameroon in 2012?
Your answer should be compact. -55.34. What is the difference between the Exports(as % of merchandise exports) in Benin in 2008 and the Exports(as % of merchandise exports) in Congo (Republic) in 2012?
Provide a short and direct response. -78.63. What is the difference between the Exports(as % of merchandise exports) in Benin in 2008 and the Exports(as % of merchandise exports) in Greenland in 2012?
Your response must be concise. 0.27. What is the difference between the Exports(as % of merchandise exports) of Cameroon in 2008 and the Exports(as % of merchandise exports) of Congo (Republic) in 2012?
Ensure brevity in your answer.  -77.65. What is the difference between the Exports(as % of merchandise exports) in Cameroon in 2008 and the Exports(as % of merchandise exports) in Greenland in 2012?
Offer a very short reply. 1.25. What is the difference between the Exports(as % of merchandise exports) in Congo (Republic) in 2008 and the Exports(as % of merchandise exports) in Greenland in 2012?
Your answer should be very brief. 84.09. What is the difference between the Exports(as % of merchandise exports) in Benin in 2009 and the Exports(as % of merchandise exports) in Cameroon in 2010?
Your answer should be compact. -49.54. What is the difference between the Exports(as % of merchandise exports) of Benin in 2009 and the Exports(as % of merchandise exports) of Congo (Republic) in 2010?
Your response must be concise. -67.71. What is the difference between the Exports(as % of merchandise exports) in Benin in 2009 and the Exports(as % of merchandise exports) in Greenland in 2010?
Your response must be concise. 0.01. What is the difference between the Exports(as % of merchandise exports) in Cameroon in 2009 and the Exports(as % of merchandise exports) in Congo (Republic) in 2010?
Provide a short and direct response. -66.77. What is the difference between the Exports(as % of merchandise exports) in Cameroon in 2009 and the Exports(as % of merchandise exports) in Greenland in 2010?
Your response must be concise. 0.95. What is the difference between the Exports(as % of merchandise exports) in Congo (Republic) in 2009 and the Exports(as % of merchandise exports) in Greenland in 2010?
Keep it short and to the point. 70.66. What is the difference between the Exports(as % of merchandise exports) in Benin in 2009 and the Exports(as % of merchandise exports) in Cameroon in 2011?
Your response must be concise. -0.54. What is the difference between the Exports(as % of merchandise exports) of Benin in 2009 and the Exports(as % of merchandise exports) of Congo (Republic) in 2011?
Offer a terse response. -77.66. What is the difference between the Exports(as % of merchandise exports) of Benin in 2009 and the Exports(as % of merchandise exports) of Greenland in 2011?
Offer a terse response. 0.01. What is the difference between the Exports(as % of merchandise exports) of Cameroon in 2009 and the Exports(as % of merchandise exports) of Congo (Republic) in 2011?
Your answer should be compact. -76.72. What is the difference between the Exports(as % of merchandise exports) of Cameroon in 2009 and the Exports(as % of merchandise exports) of Greenland in 2011?
Ensure brevity in your answer.  0.95. What is the difference between the Exports(as % of merchandise exports) in Congo (Republic) in 2009 and the Exports(as % of merchandise exports) in Greenland in 2011?
Your answer should be very brief. 70.66. What is the difference between the Exports(as % of merchandise exports) of Benin in 2009 and the Exports(as % of merchandise exports) of Cameroon in 2012?
Keep it short and to the point. -55.6. What is the difference between the Exports(as % of merchandise exports) of Benin in 2009 and the Exports(as % of merchandise exports) of Congo (Republic) in 2012?
Provide a succinct answer. -78.89. What is the difference between the Exports(as % of merchandise exports) of Benin in 2009 and the Exports(as % of merchandise exports) of Greenland in 2012?
Keep it short and to the point. 0.01. What is the difference between the Exports(as % of merchandise exports) in Cameroon in 2009 and the Exports(as % of merchandise exports) in Congo (Republic) in 2012?
Your answer should be very brief. -77.95. What is the difference between the Exports(as % of merchandise exports) in Cameroon in 2009 and the Exports(as % of merchandise exports) in Greenland in 2012?
Your answer should be very brief. 0.95. What is the difference between the Exports(as % of merchandise exports) of Congo (Republic) in 2009 and the Exports(as % of merchandise exports) of Greenland in 2012?
Offer a terse response. 70.66. What is the difference between the Exports(as % of merchandise exports) in Benin in 2010 and the Exports(as % of merchandise exports) in Cameroon in 2011?
Your response must be concise. -0.54. What is the difference between the Exports(as % of merchandise exports) of Benin in 2010 and the Exports(as % of merchandise exports) of Congo (Republic) in 2011?
Offer a very short reply. -77.66. What is the difference between the Exports(as % of merchandise exports) of Benin in 2010 and the Exports(as % of merchandise exports) of Greenland in 2011?
Offer a terse response. 0.01. What is the difference between the Exports(as % of merchandise exports) of Cameroon in 2010 and the Exports(as % of merchandise exports) of Congo (Republic) in 2011?
Ensure brevity in your answer.  -28.12. What is the difference between the Exports(as % of merchandise exports) of Cameroon in 2010 and the Exports(as % of merchandise exports) of Greenland in 2011?
Your answer should be compact. 49.55. What is the difference between the Exports(as % of merchandise exports) in Congo (Republic) in 2010 and the Exports(as % of merchandise exports) in Greenland in 2011?
Offer a very short reply. 67.72. What is the difference between the Exports(as % of merchandise exports) in Benin in 2010 and the Exports(as % of merchandise exports) in Cameroon in 2012?
Your answer should be compact. -55.6. What is the difference between the Exports(as % of merchandise exports) in Benin in 2010 and the Exports(as % of merchandise exports) in Congo (Republic) in 2012?
Offer a terse response. -78.89. What is the difference between the Exports(as % of merchandise exports) in Benin in 2010 and the Exports(as % of merchandise exports) in Greenland in 2012?
Your answer should be very brief. 0.01. What is the difference between the Exports(as % of merchandise exports) of Cameroon in 2010 and the Exports(as % of merchandise exports) of Congo (Republic) in 2012?
Provide a short and direct response. -29.35. What is the difference between the Exports(as % of merchandise exports) in Cameroon in 2010 and the Exports(as % of merchandise exports) in Greenland in 2012?
Provide a short and direct response. 49.55. What is the difference between the Exports(as % of merchandise exports) of Congo (Republic) in 2010 and the Exports(as % of merchandise exports) of Greenland in 2012?
Ensure brevity in your answer.  67.72. What is the difference between the Exports(as % of merchandise exports) of Benin in 2011 and the Exports(as % of merchandise exports) of Cameroon in 2012?
Offer a terse response. -55.51. What is the difference between the Exports(as % of merchandise exports) of Benin in 2011 and the Exports(as % of merchandise exports) of Congo (Republic) in 2012?
Your answer should be very brief. -78.79. What is the difference between the Exports(as % of merchandise exports) of Benin in 2011 and the Exports(as % of merchandise exports) of Greenland in 2012?
Make the answer very short. 0.11. What is the difference between the Exports(as % of merchandise exports) in Cameroon in 2011 and the Exports(as % of merchandise exports) in Congo (Republic) in 2012?
Provide a short and direct response. -78.35. What is the difference between the Exports(as % of merchandise exports) in Cameroon in 2011 and the Exports(as % of merchandise exports) in Greenland in 2012?
Keep it short and to the point. 0.55. What is the difference between the Exports(as % of merchandise exports) of Congo (Republic) in 2011 and the Exports(as % of merchandise exports) of Greenland in 2012?
Offer a very short reply. 77.67. What is the average Exports(as % of merchandise exports) of Benin per year?
Make the answer very short. 1.39. What is the average Exports(as % of merchandise exports) in Cameroon per year?
Make the answer very short. 27.42. What is the average Exports(as % of merchandise exports) of Congo (Republic) per year?
Offer a very short reply. 79.86. What is the average Exports(as % of merchandise exports) of Greenland per year?
Your response must be concise. 0.1. In the year 1979, what is the difference between the Exports(as % of merchandise exports) of Benin and Exports(as % of merchandise exports) of Cameroon?
Make the answer very short. -21.33. In the year 1979, what is the difference between the Exports(as % of merchandise exports) of Benin and Exports(as % of merchandise exports) of Congo (Republic)?
Make the answer very short. -82.89. In the year 1979, what is the difference between the Exports(as % of merchandise exports) of Benin and Exports(as % of merchandise exports) of Greenland?
Offer a terse response. 2.25. In the year 1979, what is the difference between the Exports(as % of merchandise exports) of Cameroon and Exports(as % of merchandise exports) of Congo (Republic)?
Give a very brief answer. -61.57. In the year 1979, what is the difference between the Exports(as % of merchandise exports) in Cameroon and Exports(as % of merchandise exports) in Greenland?
Provide a short and direct response. 23.58. In the year 1979, what is the difference between the Exports(as % of merchandise exports) in Congo (Republic) and Exports(as % of merchandise exports) in Greenland?
Provide a succinct answer. 85.14. In the year 1995, what is the difference between the Exports(as % of merchandise exports) in Benin and Exports(as % of merchandise exports) in Cameroon?
Offer a very short reply. -23.75. In the year 1995, what is the difference between the Exports(as % of merchandise exports) of Benin and Exports(as % of merchandise exports) of Congo (Republic)?
Your answer should be very brief. -82.23. In the year 1995, what is the difference between the Exports(as % of merchandise exports) of Benin and Exports(as % of merchandise exports) of Greenland?
Make the answer very short. 4.62. In the year 1995, what is the difference between the Exports(as % of merchandise exports) of Cameroon and Exports(as % of merchandise exports) of Congo (Republic)?
Keep it short and to the point. -58.48. In the year 1995, what is the difference between the Exports(as % of merchandise exports) in Cameroon and Exports(as % of merchandise exports) in Greenland?
Offer a very short reply. 28.37. In the year 1995, what is the difference between the Exports(as % of merchandise exports) of Congo (Republic) and Exports(as % of merchandise exports) of Greenland?
Provide a succinct answer. 86.85. In the year 2007, what is the difference between the Exports(as % of merchandise exports) of Benin and Exports(as % of merchandise exports) of Cameroon?
Provide a succinct answer. -55.61. In the year 2007, what is the difference between the Exports(as % of merchandise exports) of Benin and Exports(as % of merchandise exports) of Congo (Republic)?
Provide a succinct answer. -83.96. In the year 2007, what is the difference between the Exports(as % of merchandise exports) in Benin and Exports(as % of merchandise exports) in Greenland?
Ensure brevity in your answer.  3.07. In the year 2007, what is the difference between the Exports(as % of merchandise exports) of Cameroon and Exports(as % of merchandise exports) of Congo (Republic)?
Give a very brief answer. -28.34. In the year 2007, what is the difference between the Exports(as % of merchandise exports) of Cameroon and Exports(as % of merchandise exports) of Greenland?
Give a very brief answer. 58.68. In the year 2007, what is the difference between the Exports(as % of merchandise exports) of Congo (Republic) and Exports(as % of merchandise exports) of Greenland?
Provide a short and direct response. 87.02. In the year 2008, what is the difference between the Exports(as % of merchandise exports) in Benin and Exports(as % of merchandise exports) in Cameroon?
Give a very brief answer. -0.98. In the year 2008, what is the difference between the Exports(as % of merchandise exports) in Benin and Exports(as % of merchandise exports) in Congo (Republic)?
Make the answer very short. -83.83. In the year 2008, what is the difference between the Exports(as % of merchandise exports) in Benin and Exports(as % of merchandise exports) in Greenland?
Provide a succinct answer. 0.27. In the year 2008, what is the difference between the Exports(as % of merchandise exports) in Cameroon and Exports(as % of merchandise exports) in Congo (Republic)?
Your answer should be very brief. -82.85. In the year 2008, what is the difference between the Exports(as % of merchandise exports) in Cameroon and Exports(as % of merchandise exports) in Greenland?
Ensure brevity in your answer.  1.25. In the year 2008, what is the difference between the Exports(as % of merchandise exports) of Congo (Republic) and Exports(as % of merchandise exports) of Greenland?
Your answer should be compact. 84.09. In the year 2009, what is the difference between the Exports(as % of merchandise exports) in Benin and Exports(as % of merchandise exports) in Cameroon?
Offer a very short reply. -0.94. In the year 2009, what is the difference between the Exports(as % of merchandise exports) of Benin and Exports(as % of merchandise exports) of Congo (Republic)?
Provide a short and direct response. -70.65. In the year 2009, what is the difference between the Exports(as % of merchandise exports) of Benin and Exports(as % of merchandise exports) of Greenland?
Offer a very short reply. 0.01. In the year 2009, what is the difference between the Exports(as % of merchandise exports) of Cameroon and Exports(as % of merchandise exports) of Congo (Republic)?
Your answer should be compact. -69.71. In the year 2009, what is the difference between the Exports(as % of merchandise exports) in Congo (Republic) and Exports(as % of merchandise exports) in Greenland?
Give a very brief answer. 70.66. In the year 2010, what is the difference between the Exports(as % of merchandise exports) in Benin and Exports(as % of merchandise exports) in Cameroon?
Keep it short and to the point. -49.54. In the year 2010, what is the difference between the Exports(as % of merchandise exports) of Benin and Exports(as % of merchandise exports) of Congo (Republic)?
Offer a terse response. -67.71. In the year 2010, what is the difference between the Exports(as % of merchandise exports) in Benin and Exports(as % of merchandise exports) in Greenland?
Make the answer very short. 0.01. In the year 2010, what is the difference between the Exports(as % of merchandise exports) of Cameroon and Exports(as % of merchandise exports) of Congo (Republic)?
Give a very brief answer. -18.17. In the year 2010, what is the difference between the Exports(as % of merchandise exports) of Cameroon and Exports(as % of merchandise exports) of Greenland?
Your response must be concise. 49.55. In the year 2010, what is the difference between the Exports(as % of merchandise exports) in Congo (Republic) and Exports(as % of merchandise exports) in Greenland?
Offer a terse response. 67.72. In the year 2011, what is the difference between the Exports(as % of merchandise exports) in Benin and Exports(as % of merchandise exports) in Cameroon?
Ensure brevity in your answer.  -0.45. In the year 2011, what is the difference between the Exports(as % of merchandise exports) of Benin and Exports(as % of merchandise exports) of Congo (Republic)?
Provide a short and direct response. -77.56. In the year 2011, what is the difference between the Exports(as % of merchandise exports) of Benin and Exports(as % of merchandise exports) of Greenland?
Provide a short and direct response. 0.11. In the year 2011, what is the difference between the Exports(as % of merchandise exports) of Cameroon and Exports(as % of merchandise exports) of Congo (Republic)?
Your response must be concise. -77.11. In the year 2011, what is the difference between the Exports(as % of merchandise exports) in Cameroon and Exports(as % of merchandise exports) in Greenland?
Your answer should be very brief. 0.55. In the year 2011, what is the difference between the Exports(as % of merchandise exports) in Congo (Republic) and Exports(as % of merchandise exports) in Greenland?
Make the answer very short. 77.67. In the year 2012, what is the difference between the Exports(as % of merchandise exports) of Benin and Exports(as % of merchandise exports) of Cameroon?
Your answer should be compact. -55.61. In the year 2012, what is the difference between the Exports(as % of merchandise exports) in Benin and Exports(as % of merchandise exports) in Congo (Republic)?
Your response must be concise. -78.89. In the year 2012, what is the difference between the Exports(as % of merchandise exports) of Benin and Exports(as % of merchandise exports) of Greenland?
Keep it short and to the point. 0.01. In the year 2012, what is the difference between the Exports(as % of merchandise exports) of Cameroon and Exports(as % of merchandise exports) of Congo (Republic)?
Ensure brevity in your answer.  -23.29. In the year 2012, what is the difference between the Exports(as % of merchandise exports) in Cameroon and Exports(as % of merchandise exports) in Greenland?
Make the answer very short. 55.61. In the year 2012, what is the difference between the Exports(as % of merchandise exports) in Congo (Republic) and Exports(as % of merchandise exports) in Greenland?
Offer a terse response. 78.9. What is the ratio of the Exports(as % of merchandise exports) in Benin in 1979 to that in 1995?
Provide a short and direct response. 0.42. What is the ratio of the Exports(as % of merchandise exports) of Cameroon in 1979 to that in 1995?
Provide a short and direct response. 0.81. What is the ratio of the Exports(as % of merchandise exports) in Congo (Republic) in 1979 to that in 1995?
Offer a terse response. 0.97. What is the ratio of the Exports(as % of merchandise exports) in Greenland in 1979 to that in 1995?
Provide a succinct answer. 0.02. What is the ratio of the Exports(as % of merchandise exports) in Benin in 1979 to that in 2007?
Make the answer very short. 0.74. What is the ratio of the Exports(as % of merchandise exports) in Cameroon in 1979 to that in 2007?
Provide a short and direct response. 0.4. What is the ratio of the Exports(as % of merchandise exports) of Congo (Republic) in 1979 to that in 2007?
Provide a short and direct response. 0.98. What is the ratio of the Exports(as % of merchandise exports) in Greenland in 1979 to that in 2007?
Keep it short and to the point. 1154.76. What is the ratio of the Exports(as % of merchandise exports) in Benin in 1979 to that in 2008?
Ensure brevity in your answer.  8.51. What is the ratio of the Exports(as % of merchandise exports) of Cameroon in 1979 to that in 2008?
Keep it short and to the point. 18.92. What is the ratio of the Exports(as % of merchandise exports) of Congo (Republic) in 1979 to that in 2008?
Make the answer very short. 1.01. What is the ratio of the Exports(as % of merchandise exports) in Greenland in 1979 to that in 2008?
Your answer should be very brief. 57.18. What is the ratio of the Exports(as % of merchandise exports) in Benin in 1979 to that in 2009?
Give a very brief answer. 284.51. What is the ratio of the Exports(as % of merchandise exports) of Cameroon in 1979 to that in 2009?
Offer a very short reply. 24.91. What is the ratio of the Exports(as % of merchandise exports) of Congo (Republic) in 1979 to that in 2009?
Provide a succinct answer. 1.21. What is the ratio of the Exports(as % of merchandise exports) of Greenland in 1979 to that in 2009?
Provide a short and direct response. 319.89. What is the ratio of the Exports(as % of merchandise exports) in Benin in 1979 to that in 2010?
Your response must be concise. 211.61. What is the ratio of the Exports(as % of merchandise exports) in Cameroon in 1979 to that in 2010?
Provide a succinct answer. 0.48. What is the ratio of the Exports(as % of merchandise exports) in Congo (Republic) in 1979 to that in 2010?
Provide a short and direct response. 1.26. What is the ratio of the Exports(as % of merchandise exports) in Greenland in 1979 to that in 2010?
Offer a very short reply. 41.21. What is the ratio of the Exports(as % of merchandise exports) of Benin in 1979 to that in 2011?
Keep it short and to the point. 21.5. What is the ratio of the Exports(as % of merchandise exports) in Cameroon in 1979 to that in 2011?
Offer a very short reply. 42.73. What is the ratio of the Exports(as % of merchandise exports) of Congo (Republic) in 1979 to that in 2011?
Ensure brevity in your answer.  1.1. What is the ratio of the Exports(as % of merchandise exports) of Greenland in 1979 to that in 2011?
Offer a very short reply. 75.95. What is the ratio of the Exports(as % of merchandise exports) of Benin in 1979 to that in 2012?
Keep it short and to the point. 443.49. What is the ratio of the Exports(as % of merchandise exports) in Cameroon in 1979 to that in 2012?
Your answer should be very brief. 0.42. What is the ratio of the Exports(as % of merchandise exports) in Congo (Republic) in 1979 to that in 2012?
Keep it short and to the point. 1.08. What is the ratio of the Exports(as % of merchandise exports) of Greenland in 1979 to that in 2012?
Your response must be concise. 154.87. What is the ratio of the Exports(as % of merchandise exports) of Benin in 1995 to that in 2007?
Keep it short and to the point. 1.77. What is the ratio of the Exports(as % of merchandise exports) of Cameroon in 1995 to that in 2007?
Provide a succinct answer. 0.5. What is the ratio of the Exports(as % of merchandise exports) of Congo (Republic) in 1995 to that in 2007?
Make the answer very short. 1.01. What is the ratio of the Exports(as % of merchandise exports) in Greenland in 1995 to that in 2007?
Offer a very short reply. 4.75e+04. What is the ratio of the Exports(as % of merchandise exports) in Benin in 1995 to that in 2008?
Keep it short and to the point. 20.3. What is the ratio of the Exports(as % of merchandise exports) of Cameroon in 1995 to that in 2008?
Provide a short and direct response. 23.39. What is the ratio of the Exports(as % of merchandise exports) in Congo (Republic) in 1995 to that in 2008?
Provide a short and direct response. 1.04. What is the ratio of the Exports(as % of merchandise exports) of Greenland in 1995 to that in 2008?
Provide a short and direct response. 2352.67. What is the ratio of the Exports(as % of merchandise exports) of Benin in 1995 to that in 2009?
Provide a succinct answer. 678.73. What is the ratio of the Exports(as % of merchandise exports) in Cameroon in 1995 to that in 2009?
Give a very brief answer. 30.78. What is the ratio of the Exports(as % of merchandise exports) of Congo (Republic) in 1995 to that in 2009?
Your answer should be very brief. 1.24. What is the ratio of the Exports(as % of merchandise exports) of Greenland in 1995 to that in 2009?
Your response must be concise. 1.32e+04. What is the ratio of the Exports(as % of merchandise exports) of Benin in 1995 to that in 2010?
Ensure brevity in your answer.  504.82. What is the ratio of the Exports(as % of merchandise exports) of Cameroon in 1995 to that in 2010?
Keep it short and to the point. 0.59. What is the ratio of the Exports(as % of merchandise exports) in Congo (Republic) in 1995 to that in 2010?
Offer a very short reply. 1.29. What is the ratio of the Exports(as % of merchandise exports) of Greenland in 1995 to that in 2010?
Ensure brevity in your answer.  1695.53. What is the ratio of the Exports(as % of merchandise exports) in Benin in 1995 to that in 2011?
Give a very brief answer. 51.3. What is the ratio of the Exports(as % of merchandise exports) in Cameroon in 1995 to that in 2011?
Ensure brevity in your answer.  52.81. What is the ratio of the Exports(as % of merchandise exports) of Congo (Republic) in 1995 to that in 2011?
Provide a succinct answer. 1.13. What is the ratio of the Exports(as % of merchandise exports) in Greenland in 1995 to that in 2011?
Provide a succinct answer. 3124.85. What is the ratio of the Exports(as % of merchandise exports) in Benin in 1995 to that in 2012?
Ensure brevity in your answer.  1058. What is the ratio of the Exports(as % of merchandise exports) in Cameroon in 1995 to that in 2012?
Keep it short and to the point. 0.52. What is the ratio of the Exports(as % of merchandise exports) of Congo (Republic) in 1995 to that in 2012?
Offer a terse response. 1.11. What is the ratio of the Exports(as % of merchandise exports) of Greenland in 1995 to that in 2012?
Provide a short and direct response. 6371.65. What is the ratio of the Exports(as % of merchandise exports) of Benin in 2007 to that in 2008?
Ensure brevity in your answer.  11.5. What is the ratio of the Exports(as % of merchandise exports) of Cameroon in 2007 to that in 2008?
Make the answer very short. 47.05. What is the ratio of the Exports(as % of merchandise exports) of Congo (Republic) in 2007 to that in 2008?
Your answer should be very brief. 1.03. What is the ratio of the Exports(as % of merchandise exports) of Greenland in 2007 to that in 2008?
Provide a short and direct response. 0.05. What is the ratio of the Exports(as % of merchandise exports) of Benin in 2007 to that in 2009?
Your answer should be compact. 384.3. What is the ratio of the Exports(as % of merchandise exports) of Cameroon in 2007 to that in 2009?
Your answer should be compact. 61.94. What is the ratio of the Exports(as % of merchandise exports) in Congo (Republic) in 2007 to that in 2009?
Offer a terse response. 1.23. What is the ratio of the Exports(as % of merchandise exports) of Greenland in 2007 to that in 2009?
Your answer should be very brief. 0.28. What is the ratio of the Exports(as % of merchandise exports) of Benin in 2007 to that in 2010?
Your response must be concise. 285.83. What is the ratio of the Exports(as % of merchandise exports) of Cameroon in 2007 to that in 2010?
Provide a succinct answer. 1.18. What is the ratio of the Exports(as % of merchandise exports) in Congo (Republic) in 2007 to that in 2010?
Offer a terse response. 1.29. What is the ratio of the Exports(as % of merchandise exports) of Greenland in 2007 to that in 2010?
Make the answer very short. 0.04. What is the ratio of the Exports(as % of merchandise exports) of Benin in 2007 to that in 2011?
Provide a short and direct response. 29.05. What is the ratio of the Exports(as % of merchandise exports) in Cameroon in 2007 to that in 2011?
Make the answer very short. 106.26. What is the ratio of the Exports(as % of merchandise exports) in Congo (Republic) in 2007 to that in 2011?
Provide a short and direct response. 1.12. What is the ratio of the Exports(as % of merchandise exports) in Greenland in 2007 to that in 2011?
Provide a short and direct response. 0.07. What is the ratio of the Exports(as % of merchandise exports) of Benin in 2007 to that in 2012?
Provide a short and direct response. 599.05. What is the ratio of the Exports(as % of merchandise exports) of Cameroon in 2007 to that in 2012?
Your response must be concise. 1.06. What is the ratio of the Exports(as % of merchandise exports) of Congo (Republic) in 2007 to that in 2012?
Make the answer very short. 1.1. What is the ratio of the Exports(as % of merchandise exports) of Greenland in 2007 to that in 2012?
Provide a succinct answer. 0.13. What is the ratio of the Exports(as % of merchandise exports) of Benin in 2008 to that in 2009?
Provide a short and direct response. 33.43. What is the ratio of the Exports(as % of merchandise exports) in Cameroon in 2008 to that in 2009?
Make the answer very short. 1.32. What is the ratio of the Exports(as % of merchandise exports) in Congo (Republic) in 2008 to that in 2009?
Keep it short and to the point. 1.19. What is the ratio of the Exports(as % of merchandise exports) in Greenland in 2008 to that in 2009?
Offer a terse response. 5.59. What is the ratio of the Exports(as % of merchandise exports) in Benin in 2008 to that in 2010?
Give a very brief answer. 24.86. What is the ratio of the Exports(as % of merchandise exports) in Cameroon in 2008 to that in 2010?
Keep it short and to the point. 0.03. What is the ratio of the Exports(as % of merchandise exports) in Congo (Republic) in 2008 to that in 2010?
Your answer should be compact. 1.24. What is the ratio of the Exports(as % of merchandise exports) of Greenland in 2008 to that in 2010?
Make the answer very short. 0.72. What is the ratio of the Exports(as % of merchandise exports) of Benin in 2008 to that in 2011?
Provide a short and direct response. 2.53. What is the ratio of the Exports(as % of merchandise exports) in Cameroon in 2008 to that in 2011?
Make the answer very short. 2.26. What is the ratio of the Exports(as % of merchandise exports) of Congo (Republic) in 2008 to that in 2011?
Offer a very short reply. 1.08. What is the ratio of the Exports(as % of merchandise exports) in Greenland in 2008 to that in 2011?
Your answer should be compact. 1.33. What is the ratio of the Exports(as % of merchandise exports) in Benin in 2008 to that in 2012?
Offer a very short reply. 52.11. What is the ratio of the Exports(as % of merchandise exports) in Cameroon in 2008 to that in 2012?
Provide a short and direct response. 0.02. What is the ratio of the Exports(as % of merchandise exports) of Congo (Republic) in 2008 to that in 2012?
Offer a terse response. 1.07. What is the ratio of the Exports(as % of merchandise exports) in Greenland in 2008 to that in 2012?
Offer a terse response. 2.71. What is the ratio of the Exports(as % of merchandise exports) of Benin in 2009 to that in 2010?
Offer a terse response. 0.74. What is the ratio of the Exports(as % of merchandise exports) of Cameroon in 2009 to that in 2010?
Make the answer very short. 0.02. What is the ratio of the Exports(as % of merchandise exports) in Congo (Republic) in 2009 to that in 2010?
Provide a succinct answer. 1.04. What is the ratio of the Exports(as % of merchandise exports) in Greenland in 2009 to that in 2010?
Provide a succinct answer. 0.13. What is the ratio of the Exports(as % of merchandise exports) in Benin in 2009 to that in 2011?
Offer a terse response. 0.08. What is the ratio of the Exports(as % of merchandise exports) of Cameroon in 2009 to that in 2011?
Keep it short and to the point. 1.72. What is the ratio of the Exports(as % of merchandise exports) in Congo (Republic) in 2009 to that in 2011?
Your response must be concise. 0.91. What is the ratio of the Exports(as % of merchandise exports) in Greenland in 2009 to that in 2011?
Provide a short and direct response. 0.24. What is the ratio of the Exports(as % of merchandise exports) of Benin in 2009 to that in 2012?
Provide a succinct answer. 1.56. What is the ratio of the Exports(as % of merchandise exports) in Cameroon in 2009 to that in 2012?
Ensure brevity in your answer.  0.02. What is the ratio of the Exports(as % of merchandise exports) of Congo (Republic) in 2009 to that in 2012?
Keep it short and to the point. 0.9. What is the ratio of the Exports(as % of merchandise exports) in Greenland in 2009 to that in 2012?
Provide a succinct answer. 0.48. What is the ratio of the Exports(as % of merchandise exports) in Benin in 2010 to that in 2011?
Provide a succinct answer. 0.1. What is the ratio of the Exports(as % of merchandise exports) of Cameroon in 2010 to that in 2011?
Keep it short and to the point. 89.72. What is the ratio of the Exports(as % of merchandise exports) in Congo (Republic) in 2010 to that in 2011?
Your answer should be very brief. 0.87. What is the ratio of the Exports(as % of merchandise exports) in Greenland in 2010 to that in 2011?
Your answer should be compact. 1.84. What is the ratio of the Exports(as % of merchandise exports) of Benin in 2010 to that in 2012?
Provide a succinct answer. 2.1. What is the ratio of the Exports(as % of merchandise exports) in Cameroon in 2010 to that in 2012?
Your answer should be very brief. 0.89. What is the ratio of the Exports(as % of merchandise exports) of Congo (Republic) in 2010 to that in 2012?
Offer a very short reply. 0.86. What is the ratio of the Exports(as % of merchandise exports) in Greenland in 2010 to that in 2012?
Offer a terse response. 3.76. What is the ratio of the Exports(as % of merchandise exports) of Benin in 2011 to that in 2012?
Your response must be concise. 20.62. What is the ratio of the Exports(as % of merchandise exports) of Cameroon in 2011 to that in 2012?
Provide a succinct answer. 0.01. What is the ratio of the Exports(as % of merchandise exports) of Congo (Republic) in 2011 to that in 2012?
Your response must be concise. 0.98. What is the ratio of the Exports(as % of merchandise exports) of Greenland in 2011 to that in 2012?
Keep it short and to the point. 2.04. What is the difference between the highest and the second highest Exports(as % of merchandise exports) of Benin?
Your answer should be compact. 2.35. What is the difference between the highest and the second highest Exports(as % of merchandise exports) in Cameroon?
Provide a short and direct response. 3.07. What is the difference between the highest and the second highest Exports(as % of merchandise exports) in Congo (Republic)?
Make the answer very short. 0.62. What is the difference between the highest and the second highest Exports(as % of merchandise exports) in Greenland?
Provide a short and direct response. 0.77. What is the difference between the highest and the lowest Exports(as % of merchandise exports) in Benin?
Give a very brief answer. 5.41. What is the difference between the highest and the lowest Exports(as % of merchandise exports) of Cameroon?
Your answer should be compact. 58.13. What is the difference between the highest and the lowest Exports(as % of merchandise exports) in Congo (Republic)?
Make the answer very short. 19.92. What is the difference between the highest and the lowest Exports(as % of merchandise exports) of Greenland?
Your response must be concise. 0.79. 